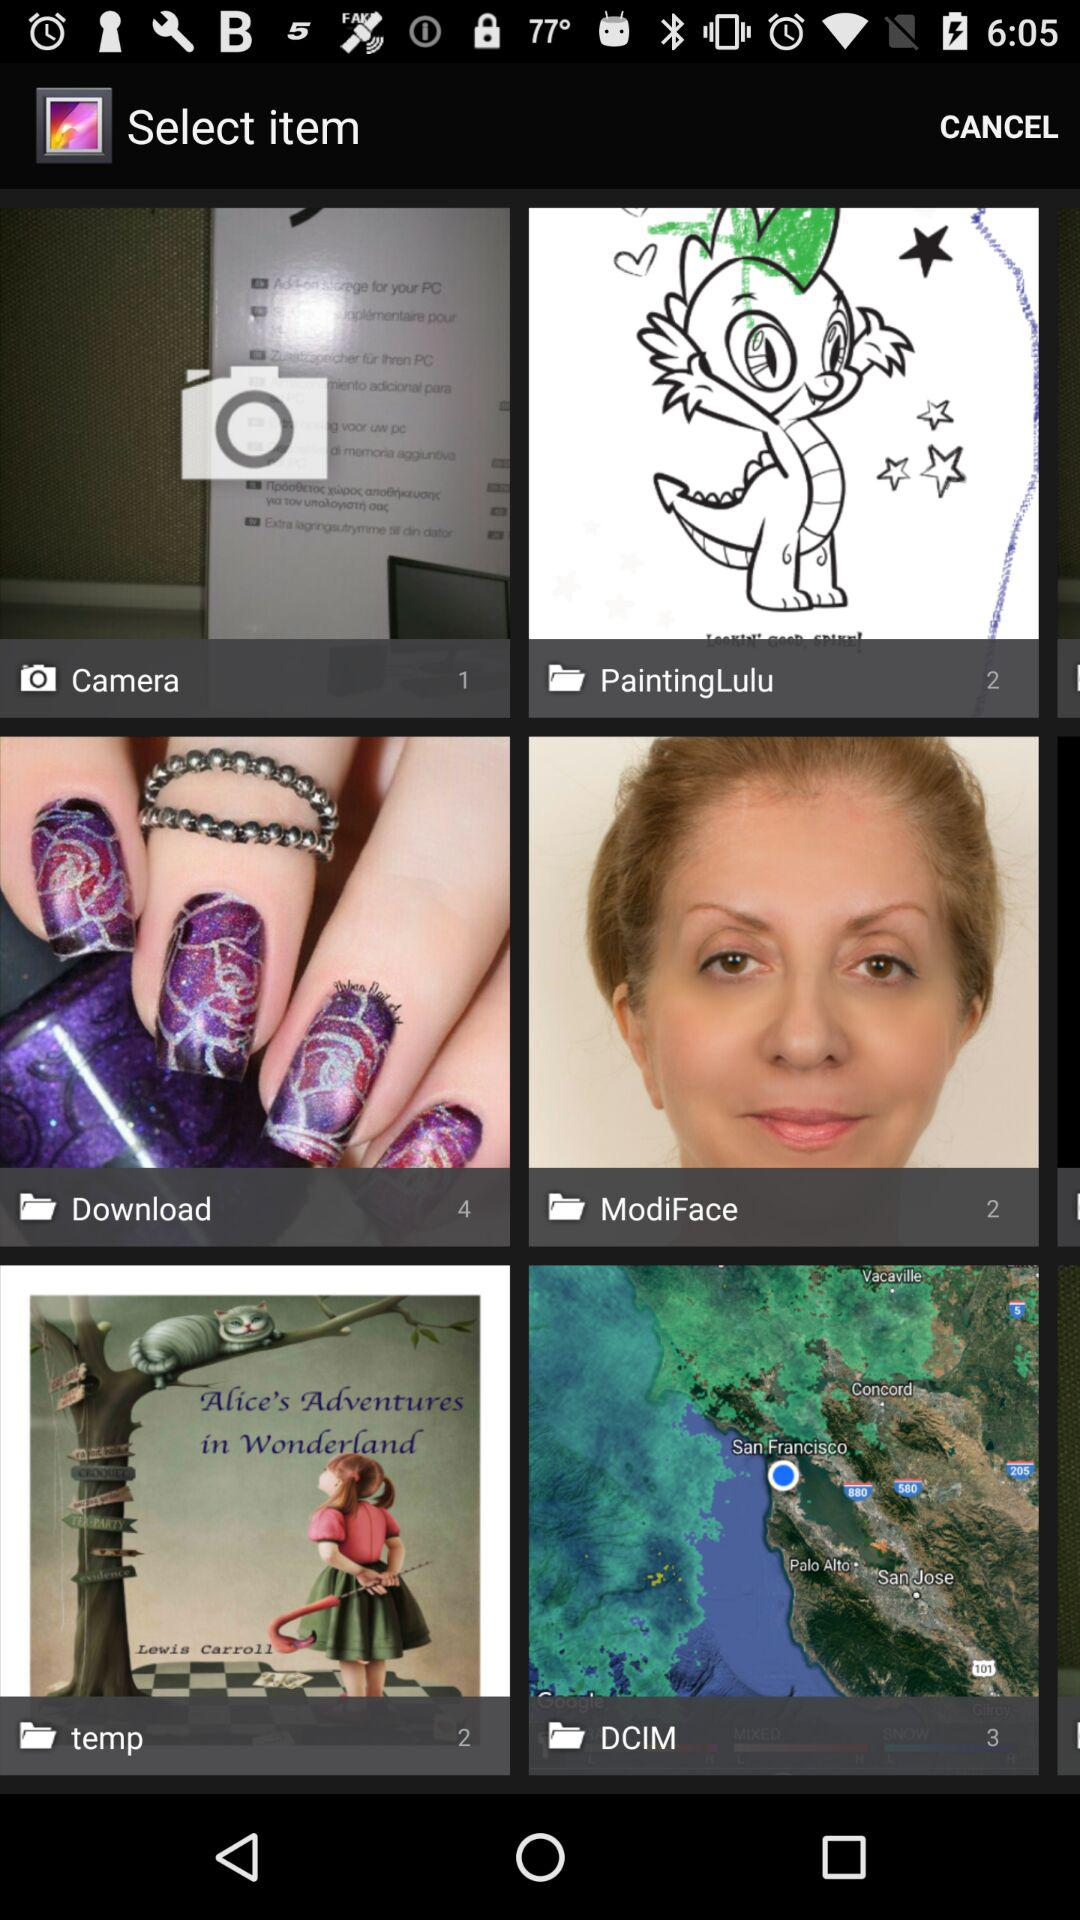Which item is selected?
When the provided information is insufficient, respond with <no answer>. <no answer> 